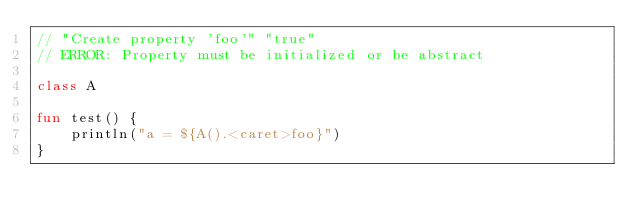Convert code to text. <code><loc_0><loc_0><loc_500><loc_500><_Kotlin_>// "Create property 'foo'" "true"
// ERROR: Property must be initialized or be abstract

class A

fun test() {
    println("a = ${A().<caret>foo}")
}</code> 